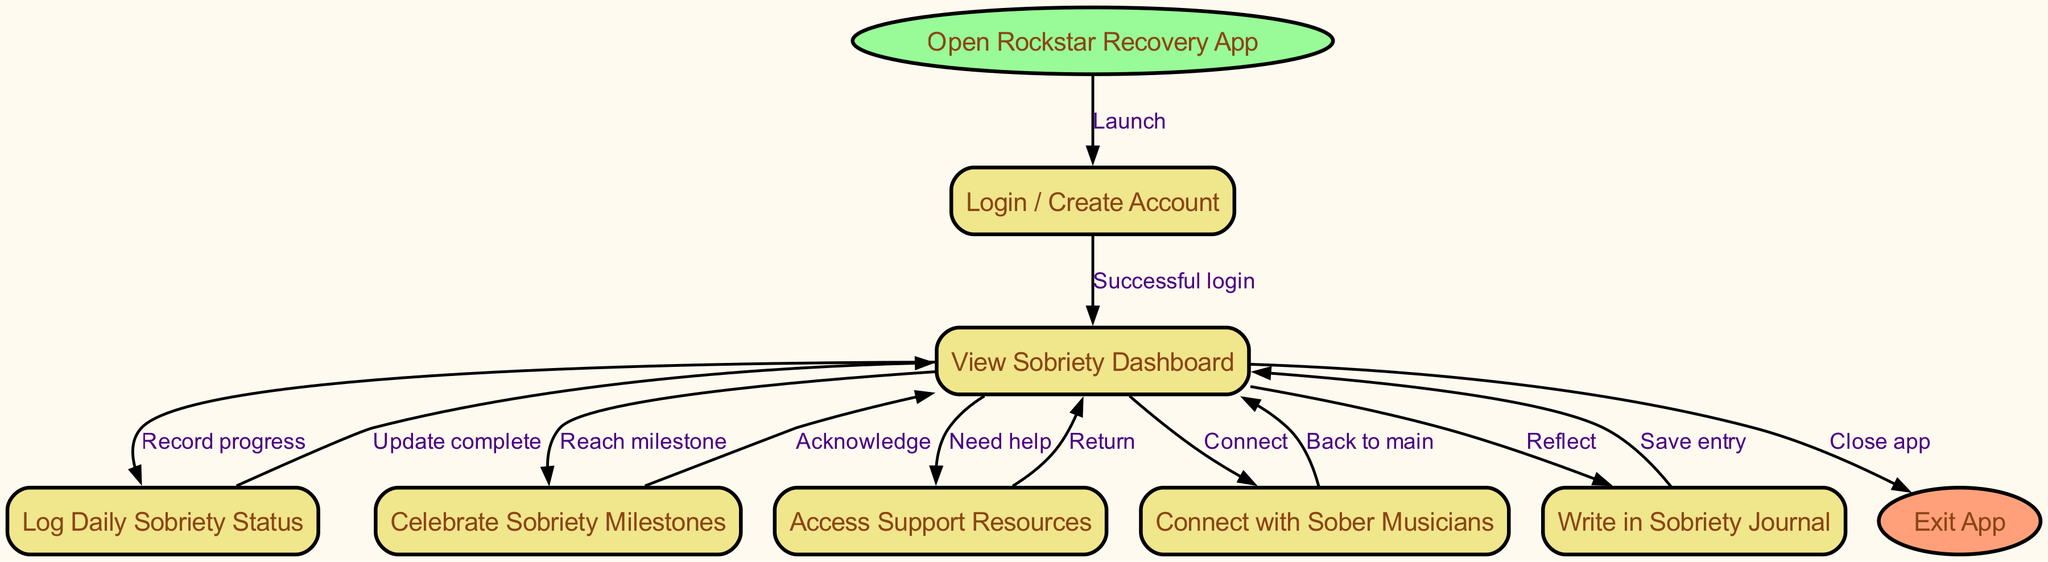What is the first step in the app's usage? The first node in the flowchart is labeled "Open Rockstar Recovery App," indicating that this is the starting point for users when using the app.
Answer: Open Rockstar Recovery App How many nodes are present in the diagram? The diagram has a total of eleven nodes listed, including all distinct steps such as login, dashboard, and milestones, among others.
Answer: Eleven What action follows a successful login? The diagram indicates that after a successful login, the next step is to "View Sobriety Dashboard," which serves as the main interface for users.
Answer: View Sobriety Dashboard Which node represents the option to connect with peers? The node titled "Connect with Sober Musicians" directly addresses user interactions aimed at establishing connections with other sober individuals within the app.
Answer: Connect with Sober Musicians What happens when a user reaches a milestone? Upon reaching a milestone, the diagram shows that the action taken is to "Celebrate Sobriety Milestones," indicating a positive reinforcement step in the user's journey.
Answer: Celebrate Sobriety Milestones If a user logs their daily sobriety status, what is the next step? After logging daily sobriety status, the flowchart leads back to the "View Sobriety Dashboard," allowing the user to see their updated progress after the logging action.
Answer: Update complete What is the final action users can take in this flow? The last step in the flowchart is labeled "Exit App," which indicates the process by which users can terminate their session within the application.
Answer: Exit App Which node provides access to resources for support? The node labeled "Access Support Resources" specifically corresponds to actions taken when users seek assistance or additional information regarding their sobriety.
Answer: Access Support Resources How many edges connect the "dashboard" node to other nodes? The "dashboard" node is connected to five different nodes: track, milestone, support, community, and journal, signifying multiple pathways for user engagement.
Answer: Five 